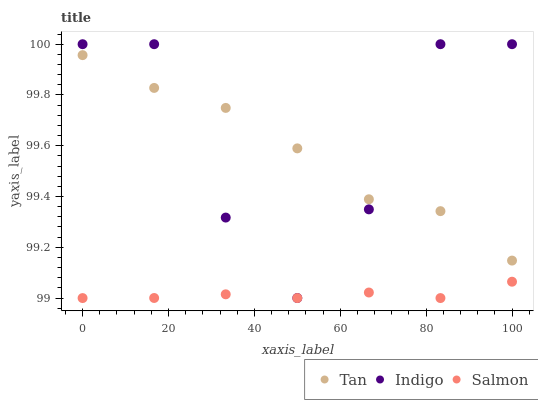Does Salmon have the minimum area under the curve?
Answer yes or no. Yes. Does Indigo have the maximum area under the curve?
Answer yes or no. Yes. Does Tan have the minimum area under the curve?
Answer yes or no. No. Does Tan have the maximum area under the curve?
Answer yes or no. No. Is Salmon the smoothest?
Answer yes or no. Yes. Is Indigo the roughest?
Answer yes or no. Yes. Is Tan the smoothest?
Answer yes or no. No. Is Tan the roughest?
Answer yes or no. No. Does Salmon have the lowest value?
Answer yes or no. Yes. Does Indigo have the lowest value?
Answer yes or no. No. Does Indigo have the highest value?
Answer yes or no. Yes. Does Tan have the highest value?
Answer yes or no. No. Is Salmon less than Tan?
Answer yes or no. Yes. Is Indigo greater than Salmon?
Answer yes or no. Yes. Does Tan intersect Indigo?
Answer yes or no. Yes. Is Tan less than Indigo?
Answer yes or no. No. Is Tan greater than Indigo?
Answer yes or no. No. Does Salmon intersect Tan?
Answer yes or no. No. 